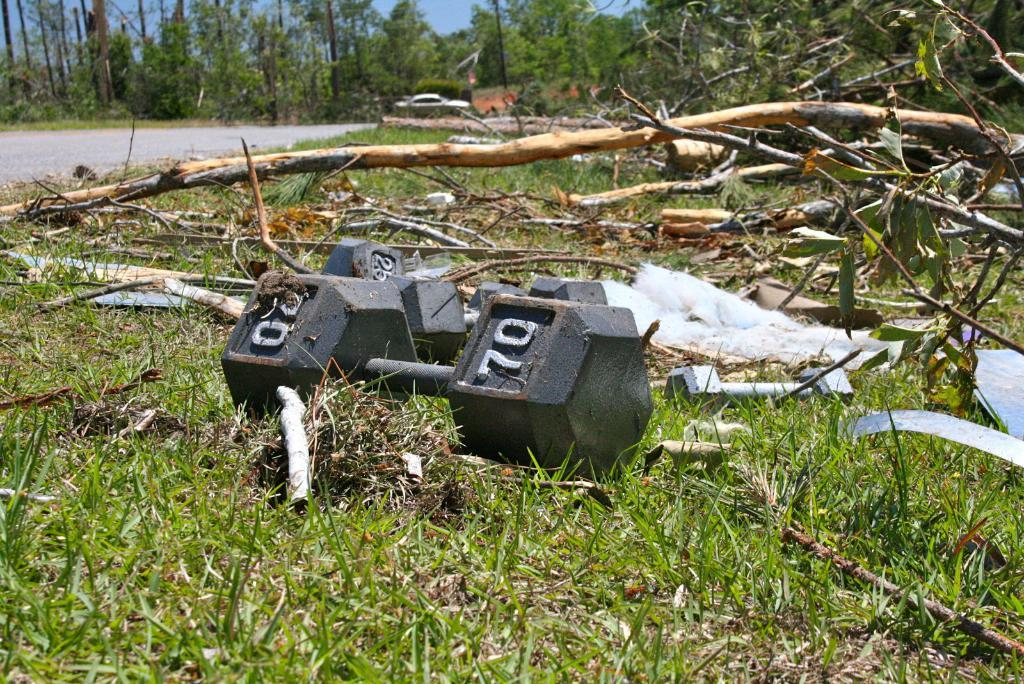What type of exercise equipment can be seen in the grass? There are dumbbells in the grass. What is located on the left side of the image? There is a road on the left side of the image. How does the whistle affect the growth of the roots in the image? There is no whistle or roots present in the image, so this question cannot be answered. 